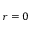Convert formula to latex. <formula><loc_0><loc_0><loc_500><loc_500>\boldsymbol r = 0</formula> 